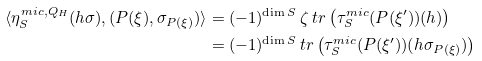Convert formula to latex. <formula><loc_0><loc_0><loc_500><loc_500>\langle \eta _ { S } ^ { m i c , Q _ { H } } ( h \sigma ) , ( P ( \xi ) , \sigma _ { P ( \xi ) } ) \rangle & = ( - 1 ) ^ { \dim S } \, \zeta \ t r \left ( \tau _ { S } ^ { m i c } ( P ( \xi ^ { \prime } ) ) ( h ) \right ) \\ & = ( - 1 ) ^ { \dim S } \, t r \left ( \tau _ { S } ^ { m i c } ( P ( \xi ^ { \prime } ) ) ( h \sigma _ { P ( \xi ) } ) \right )</formula> 